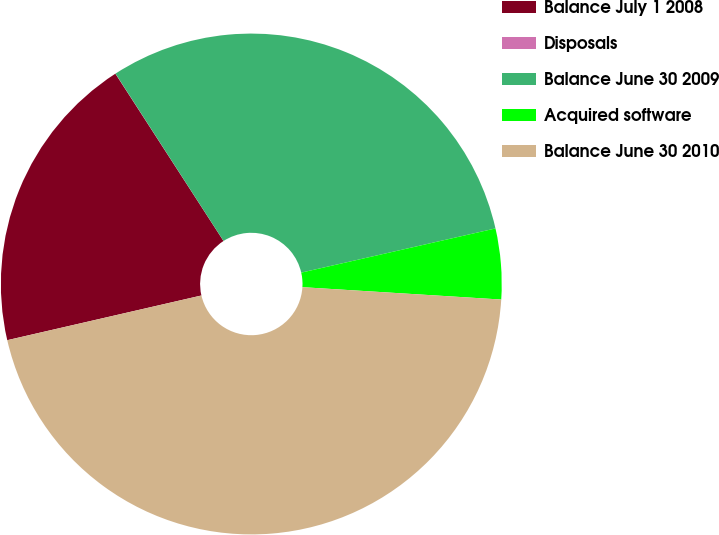Convert chart. <chart><loc_0><loc_0><loc_500><loc_500><pie_chart><fcel>Balance July 1 2008<fcel>Disposals<fcel>Balance June 30 2009<fcel>Acquired software<fcel>Balance June 30 2010<nl><fcel>19.47%<fcel>0.01%<fcel>30.56%<fcel>4.55%<fcel>45.41%<nl></chart> 